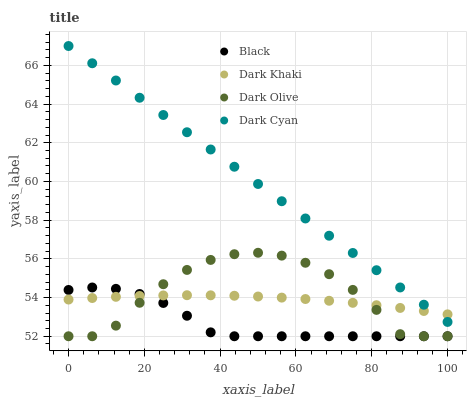Does Black have the minimum area under the curve?
Answer yes or no. Yes. Does Dark Cyan have the maximum area under the curve?
Answer yes or no. Yes. Does Dark Olive have the minimum area under the curve?
Answer yes or no. No. Does Dark Olive have the maximum area under the curve?
Answer yes or no. No. Is Dark Cyan the smoothest?
Answer yes or no. Yes. Is Dark Olive the roughest?
Answer yes or no. Yes. Is Dark Olive the smoothest?
Answer yes or no. No. Is Dark Cyan the roughest?
Answer yes or no. No. Does Dark Olive have the lowest value?
Answer yes or no. Yes. Does Dark Cyan have the lowest value?
Answer yes or no. No. Does Dark Cyan have the highest value?
Answer yes or no. Yes. Does Dark Olive have the highest value?
Answer yes or no. No. Is Dark Olive less than Dark Cyan?
Answer yes or no. Yes. Is Dark Cyan greater than Black?
Answer yes or no. Yes. Does Dark Olive intersect Dark Khaki?
Answer yes or no. Yes. Is Dark Olive less than Dark Khaki?
Answer yes or no. No. Is Dark Olive greater than Dark Khaki?
Answer yes or no. No. Does Dark Olive intersect Dark Cyan?
Answer yes or no. No. 